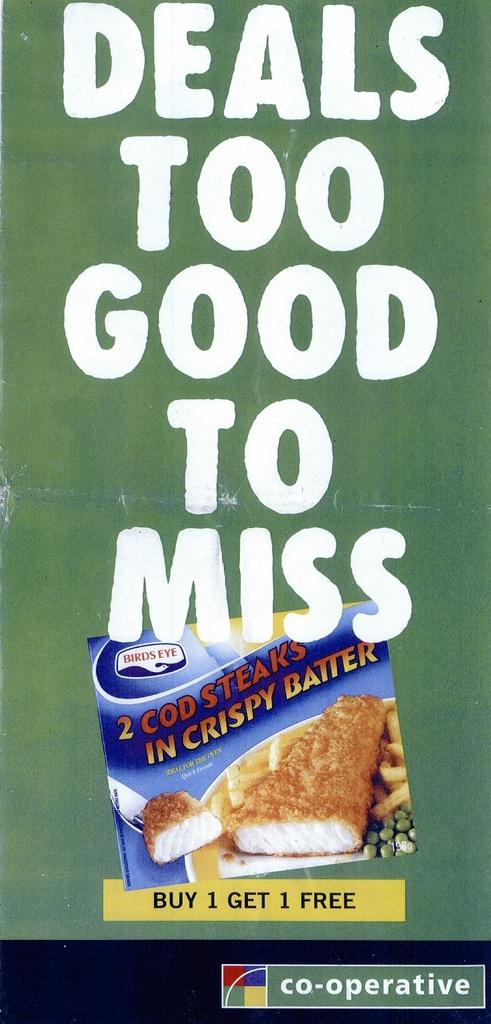What is featured in the picture? There is a poster in the picture. What can be found on the poster? The poster has text and a picture on it. Is there any text visible outside of the poster? Yes, there is text at the bottom right corner of the picture. Can you see your mom in the picture? There is no person, including your mom, visible in the picture; it only features a poster. What season is depicted in the picture? The provided facts do not mention any season or weather-related details, so it cannot be determined from the image. 